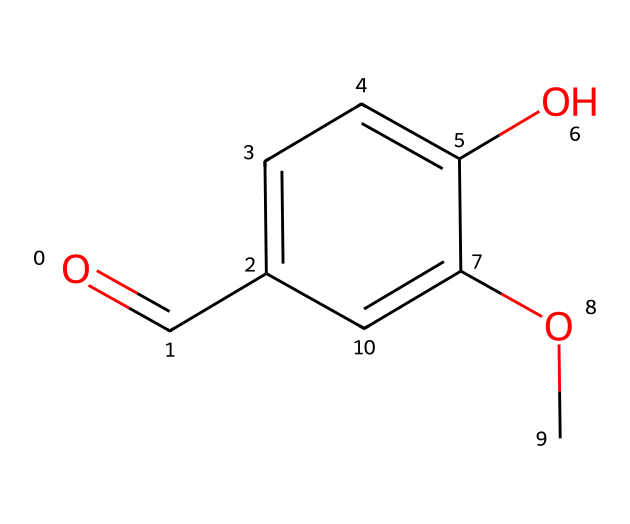What is the common name for this chemical? The chemical structure corresponds to vanillin, which is commonly known as the compound that gives vanilla its flavor and aroma.
Answer: vanillin How many carbon atoms are in vanillin? Looking at the SMILES representation and counting the carbon (C) symbols indicates there are eight carbon atoms present in the chemical structure of vanillin.
Answer: 8 What functional groups are present in vanillin? Observing the structure reveals a carbonyl group (C=O) and a hydroxyl group (–OH), which are key functional groups in vanillin's chemical makeup.
Answer: carbonyl and hydroxyl How many hydrogen atoms are in vanillin? By analyzing the chemical structure and applying the tetravalency of carbon, the number of hydrogen atoms can be deduced to be eight based on the carbon and the functional groups present.
Answer: 8 What property of vanillin makes it a comforting aroma? Vanillin's pleasant sweet scent is attributed to its aromatic ring structure, which contributes to its role as a flavoring agent and its associations with comfort and familiarity.
Answer: aromatic How would you classify vanillin based on its chemical structure? Vanillin can be classified as a phenolic compound because it contains a phenol (aromatic) ring characteristic, along with an aldehyde feature.
Answer: phenolic compound Why does vanillin have a soothing effect in crisis situations? The soothing effect of vanillin in crisis situations can be attributed to its familiar and comforting aroma which can evoke positive memories and emotional responses, aiding in stress relief.
Answer: familiar aroma 